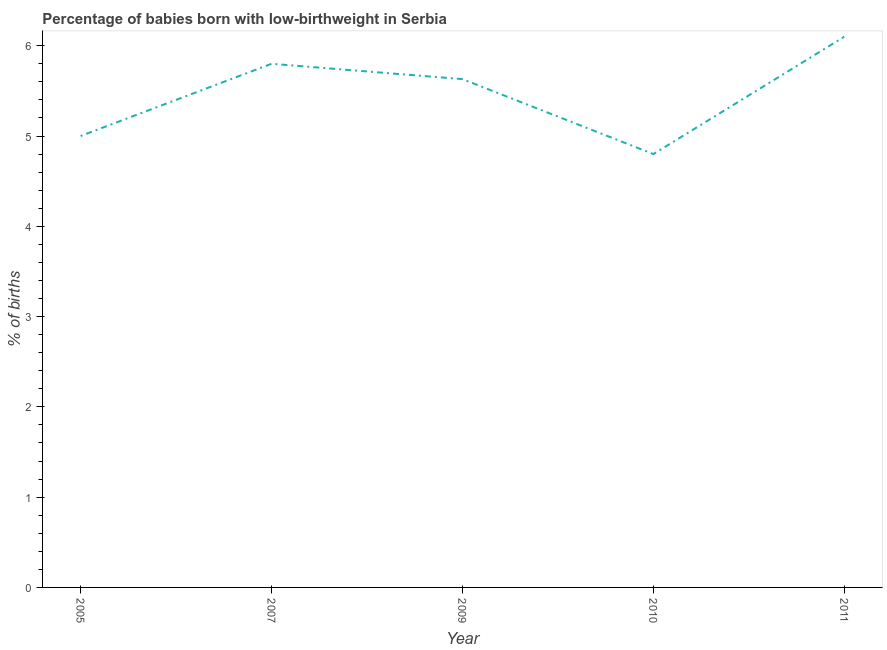Across all years, what is the maximum percentage of babies who were born with low-birthweight?
Provide a short and direct response. 6.1. In which year was the percentage of babies who were born with low-birthweight maximum?
Give a very brief answer. 2011. What is the sum of the percentage of babies who were born with low-birthweight?
Your response must be concise. 27.33. What is the difference between the percentage of babies who were born with low-birthweight in 2005 and 2010?
Provide a succinct answer. 0.2. What is the average percentage of babies who were born with low-birthweight per year?
Offer a very short reply. 5.47. What is the median percentage of babies who were born with low-birthweight?
Keep it short and to the point. 5.63. In how many years, is the percentage of babies who were born with low-birthweight greater than 5.4 %?
Your response must be concise. 3. What is the ratio of the percentage of babies who were born with low-birthweight in 2007 to that in 2011?
Your answer should be very brief. 0.95. What is the difference between the highest and the second highest percentage of babies who were born with low-birthweight?
Give a very brief answer. 0.3. Is the sum of the percentage of babies who were born with low-birthweight in 2009 and 2010 greater than the maximum percentage of babies who were born with low-birthweight across all years?
Your answer should be very brief. Yes. What is the difference between the highest and the lowest percentage of babies who were born with low-birthweight?
Offer a very short reply. 1.3. How many lines are there?
Keep it short and to the point. 1. Are the values on the major ticks of Y-axis written in scientific E-notation?
Your answer should be very brief. No. What is the title of the graph?
Provide a succinct answer. Percentage of babies born with low-birthweight in Serbia. What is the label or title of the Y-axis?
Keep it short and to the point. % of births. What is the % of births in 2005?
Offer a terse response. 5. What is the % of births in 2009?
Give a very brief answer. 5.63. What is the difference between the % of births in 2005 and 2009?
Provide a short and direct response. -0.63. What is the difference between the % of births in 2005 and 2011?
Offer a very short reply. -1.1. What is the difference between the % of births in 2007 and 2009?
Give a very brief answer. 0.17. What is the difference between the % of births in 2009 and 2010?
Ensure brevity in your answer.  0.83. What is the difference between the % of births in 2009 and 2011?
Provide a succinct answer. -0.47. What is the ratio of the % of births in 2005 to that in 2007?
Provide a succinct answer. 0.86. What is the ratio of the % of births in 2005 to that in 2009?
Your answer should be very brief. 0.89. What is the ratio of the % of births in 2005 to that in 2010?
Keep it short and to the point. 1.04. What is the ratio of the % of births in 2005 to that in 2011?
Your answer should be very brief. 0.82. What is the ratio of the % of births in 2007 to that in 2009?
Your answer should be very brief. 1.03. What is the ratio of the % of births in 2007 to that in 2010?
Your answer should be very brief. 1.21. What is the ratio of the % of births in 2007 to that in 2011?
Ensure brevity in your answer.  0.95. What is the ratio of the % of births in 2009 to that in 2010?
Offer a very short reply. 1.17. What is the ratio of the % of births in 2009 to that in 2011?
Offer a terse response. 0.92. What is the ratio of the % of births in 2010 to that in 2011?
Your answer should be very brief. 0.79. 